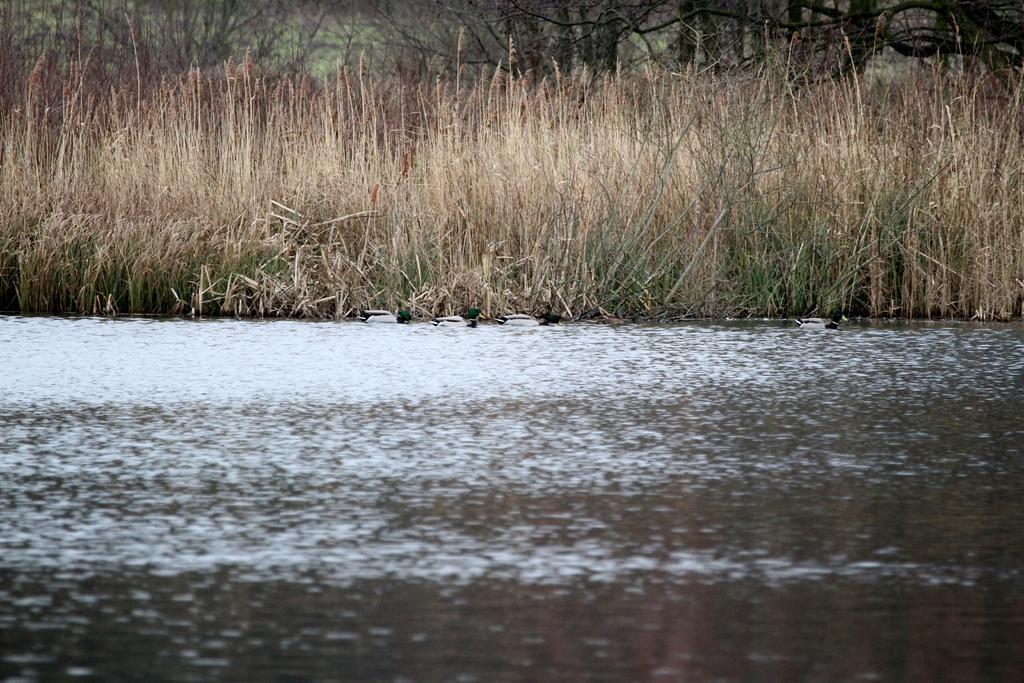Please provide a concise description of this image. In this image there is a river, grass and trees. 